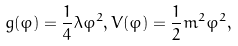<formula> <loc_0><loc_0><loc_500><loc_500>g ( \varphi ) = \frac { 1 } { 4 } \lambda \varphi ^ { 2 } , V ( \varphi ) = \frac { 1 } { 2 } m ^ { 2 } \varphi ^ { 2 } ,</formula> 